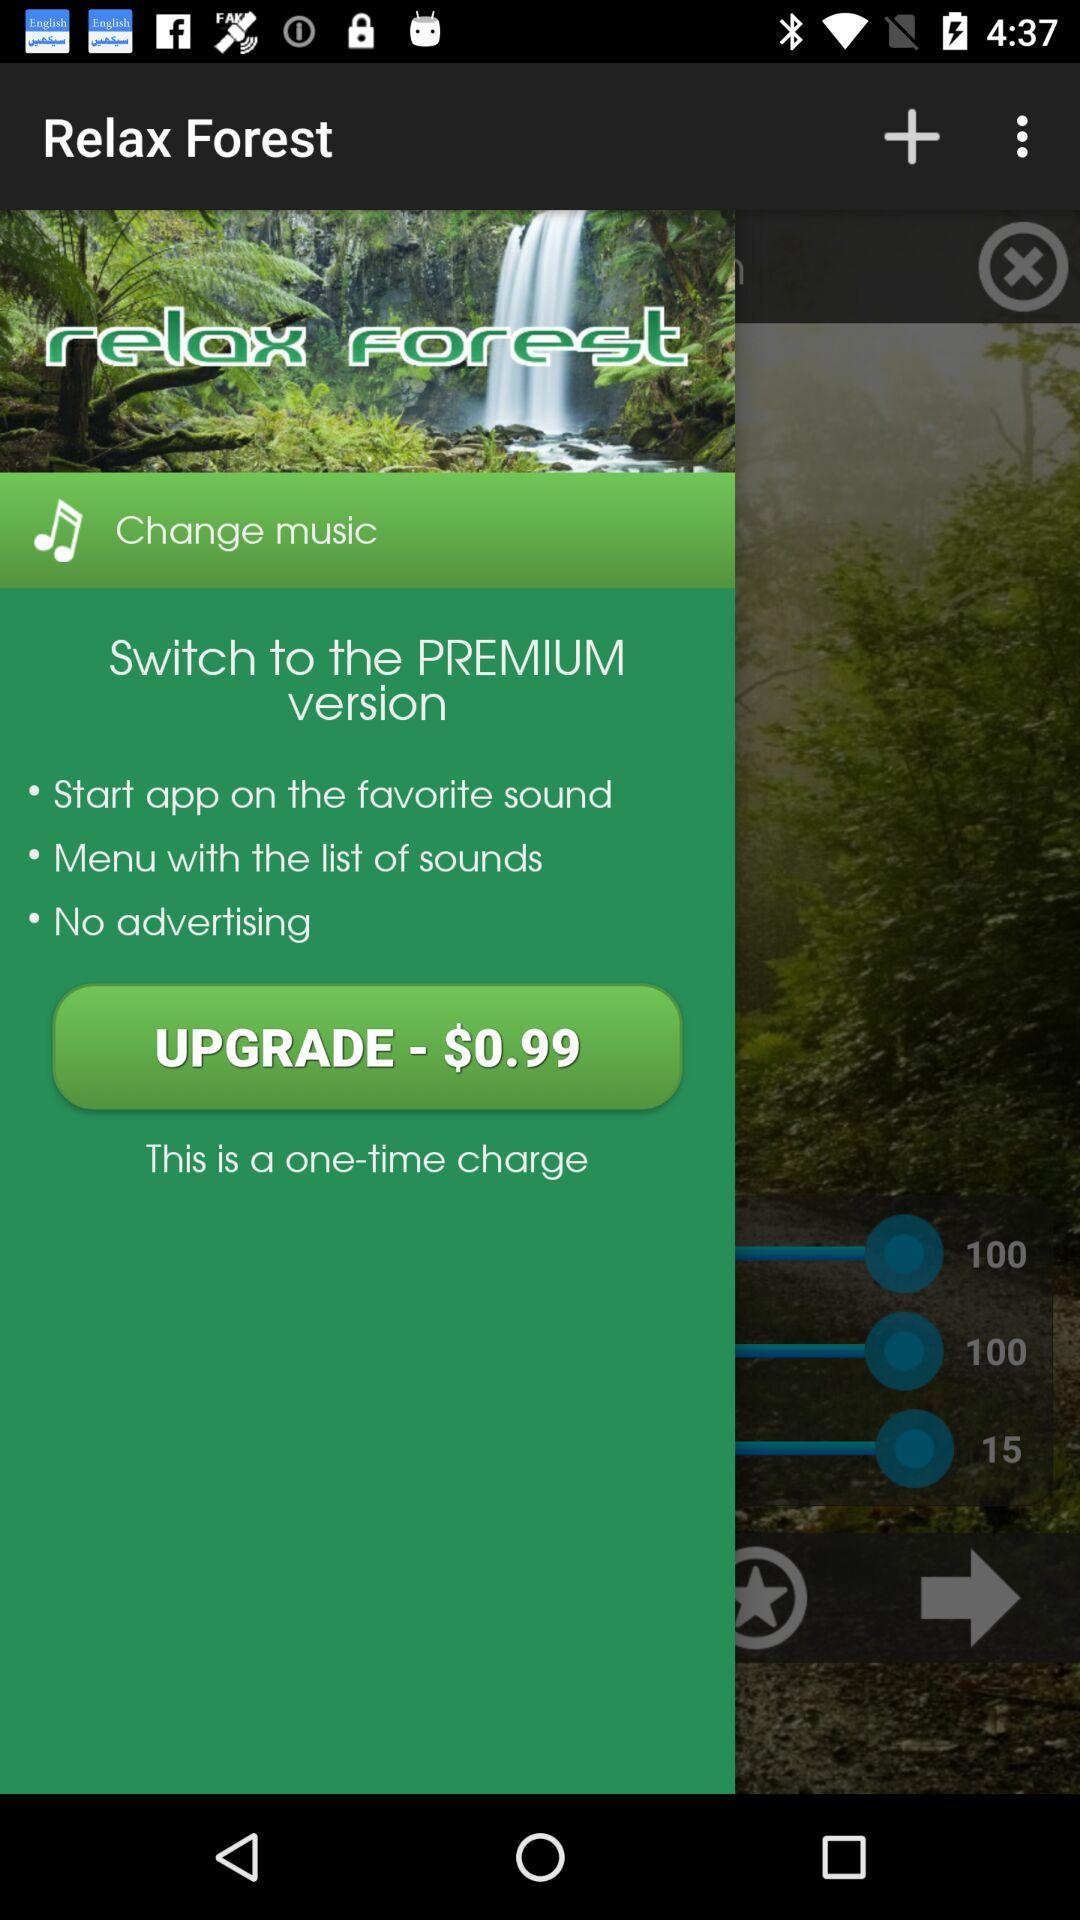How much do I have to pay to upgrade?
Answer the question using a single word or phrase. $0.99 